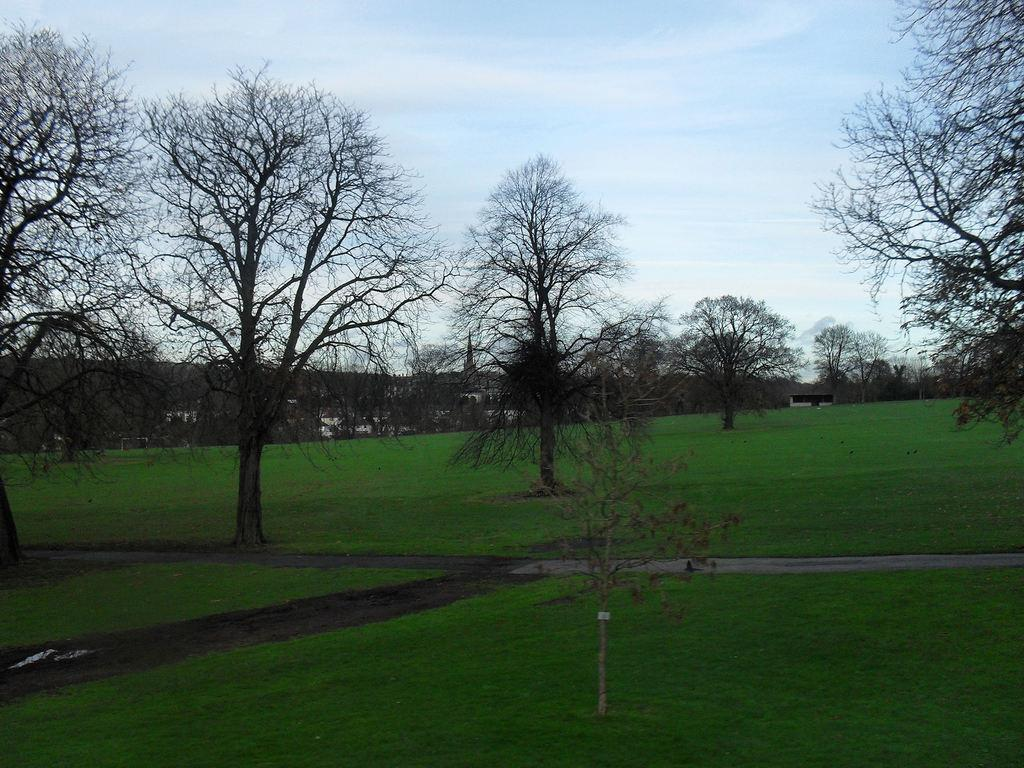What type of vegetation can be seen in the image? There are trees and grass in the image. Can you describe the natural setting in the image? The natural setting includes trees and grass. What type of cake is being served in the image? There is no cake present in the image; it only features trees and grass. Can you describe the clouds in the image? There are no clouds mentioned in the provided facts, so we cannot describe them in the image. 